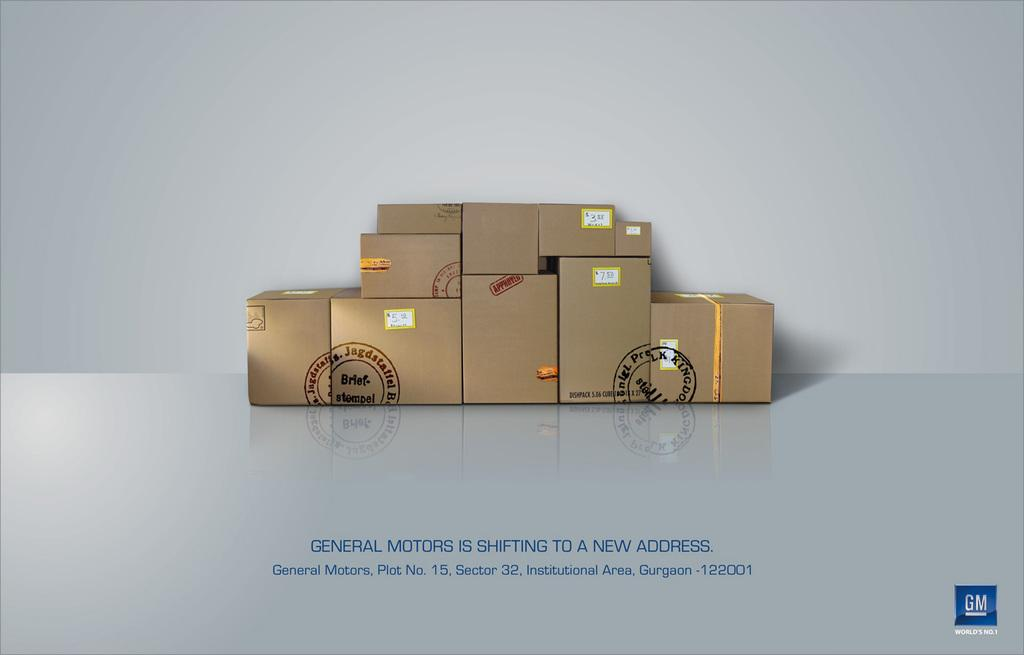Provide a one-sentence caption for the provided image. Eleven brown moving boxes stacked neatly ready to move to a new address. 